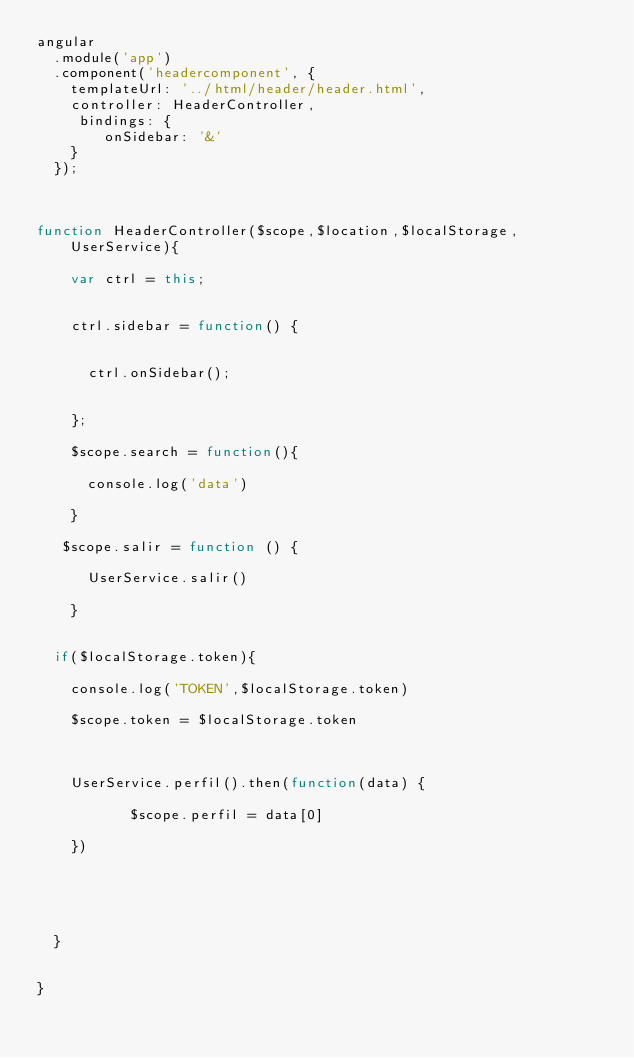<code> <loc_0><loc_0><loc_500><loc_500><_JavaScript_>angular
  .module('app')
  .component('headercomponent', {
    templateUrl: '../html/header/header.html',
    controller: HeaderController,
     bindings: {
        onSidebar: '&'
    }
  });



function HeaderController($scope,$location,$localStorage,UserService){

    var ctrl = this;


    ctrl.sidebar = function() {

    
      ctrl.onSidebar();

      
    };

    $scope.search = function(){

      console.log('data')

    }

   $scope.salir = function () {

      UserService.salir()

    }


  if($localStorage.token){

    console.log('TOKEN',$localStorage.token)

    $scope.token = $localStorage.token



    UserService.perfil().then(function(data) {

           $scope.perfil = data[0]
        
    })





  }


}
</code> 